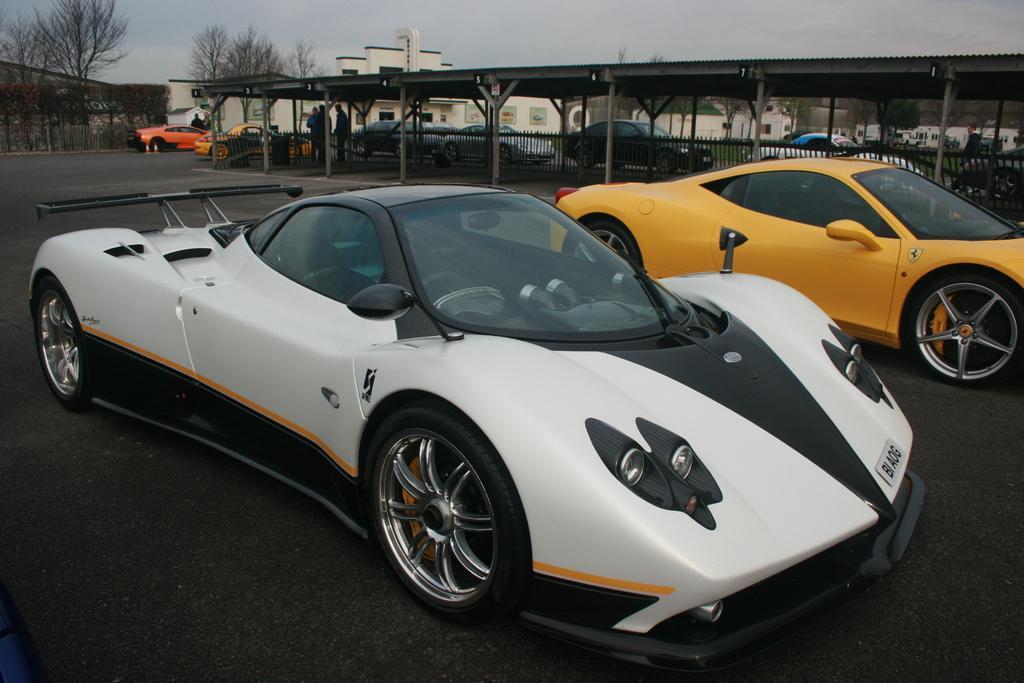Describe this image in one or two sentences. In the image there are two cars and behind the cars there is a fencing and behind that fencing there are many other cars and on the left side there are many other trees and in front of the trees there is a building. 